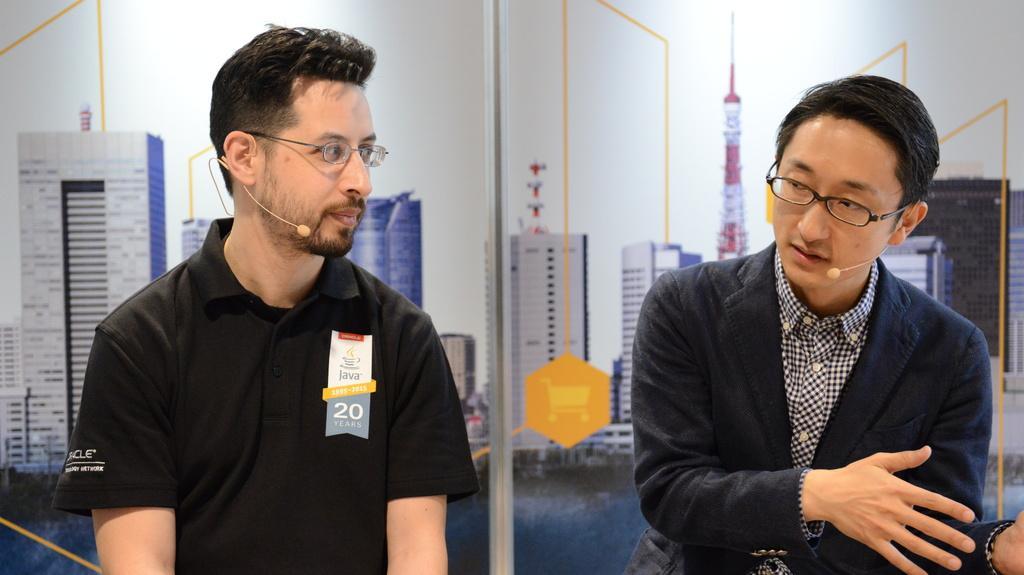Can you describe this image briefly? In the image I can see two people, among them a person is wearing the suit and behind there are some posters. 